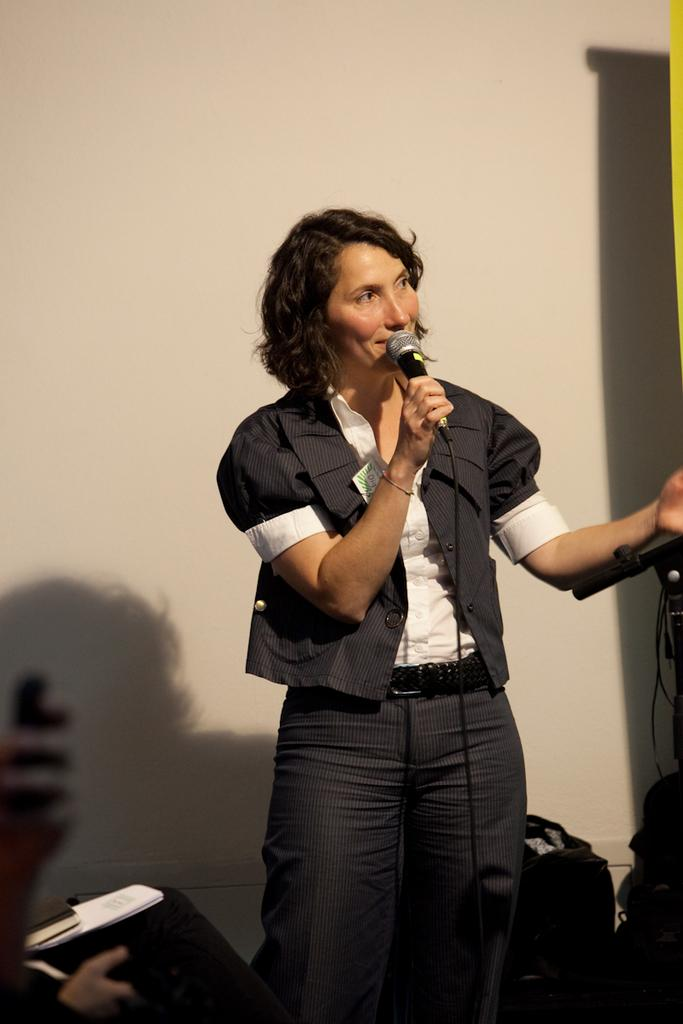Who or what is the main subject in the image? There is a person in the center of the image. What is the person holding in the image? The person is holding a microphone. What can be seen behind the person in the image? There is a wall visible in the background of the image. What type of chair is the person sitting on in the image? There is no chair present in the image; the person is standing. What kind of flesh can be seen on the person's hands in the image? There is no flesh visible on the person's hands in the image, as they are holding a microphone. 